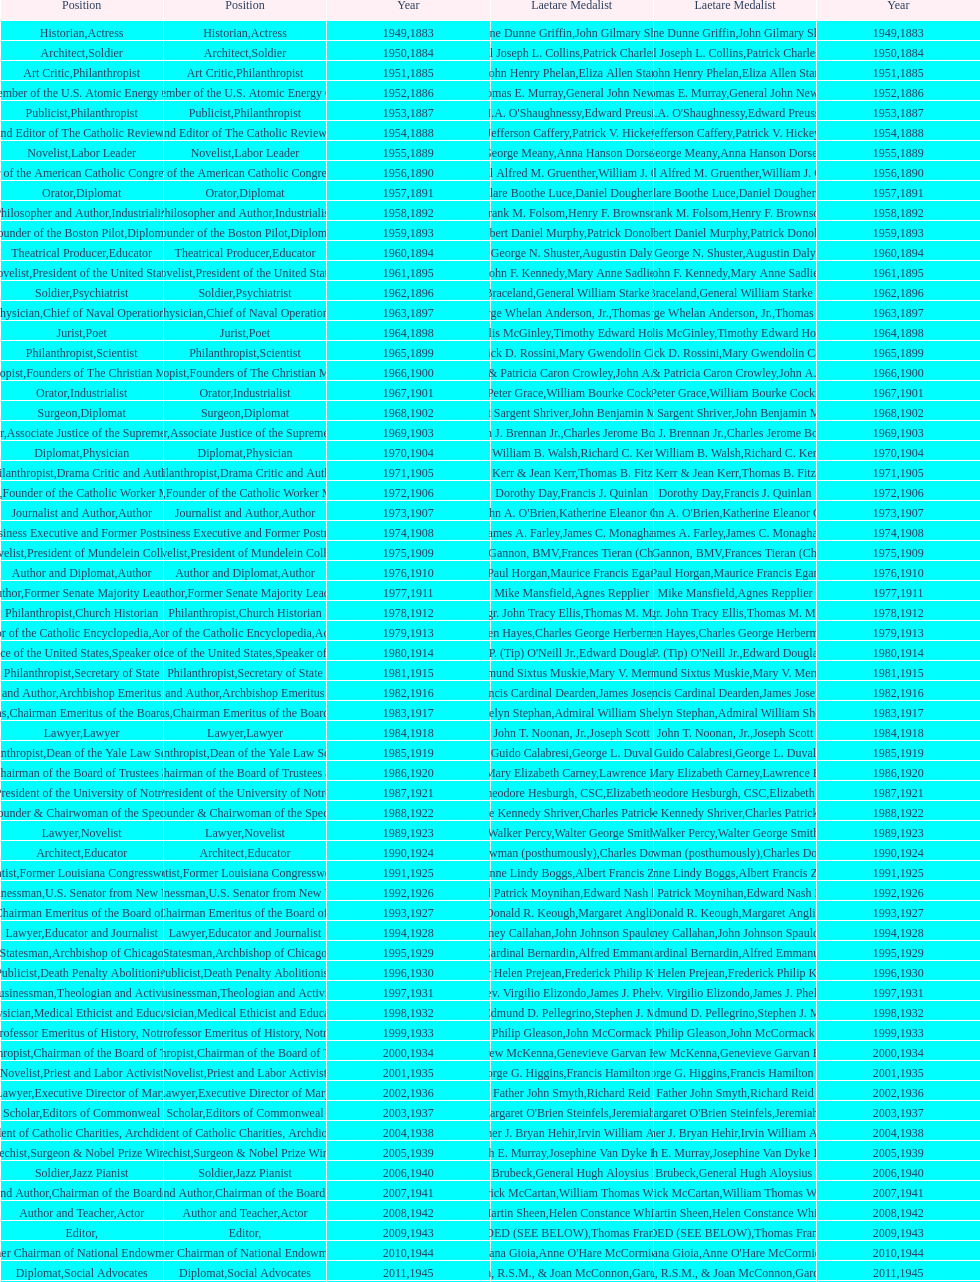How many laetare medal awardees were benefactors? 2. 